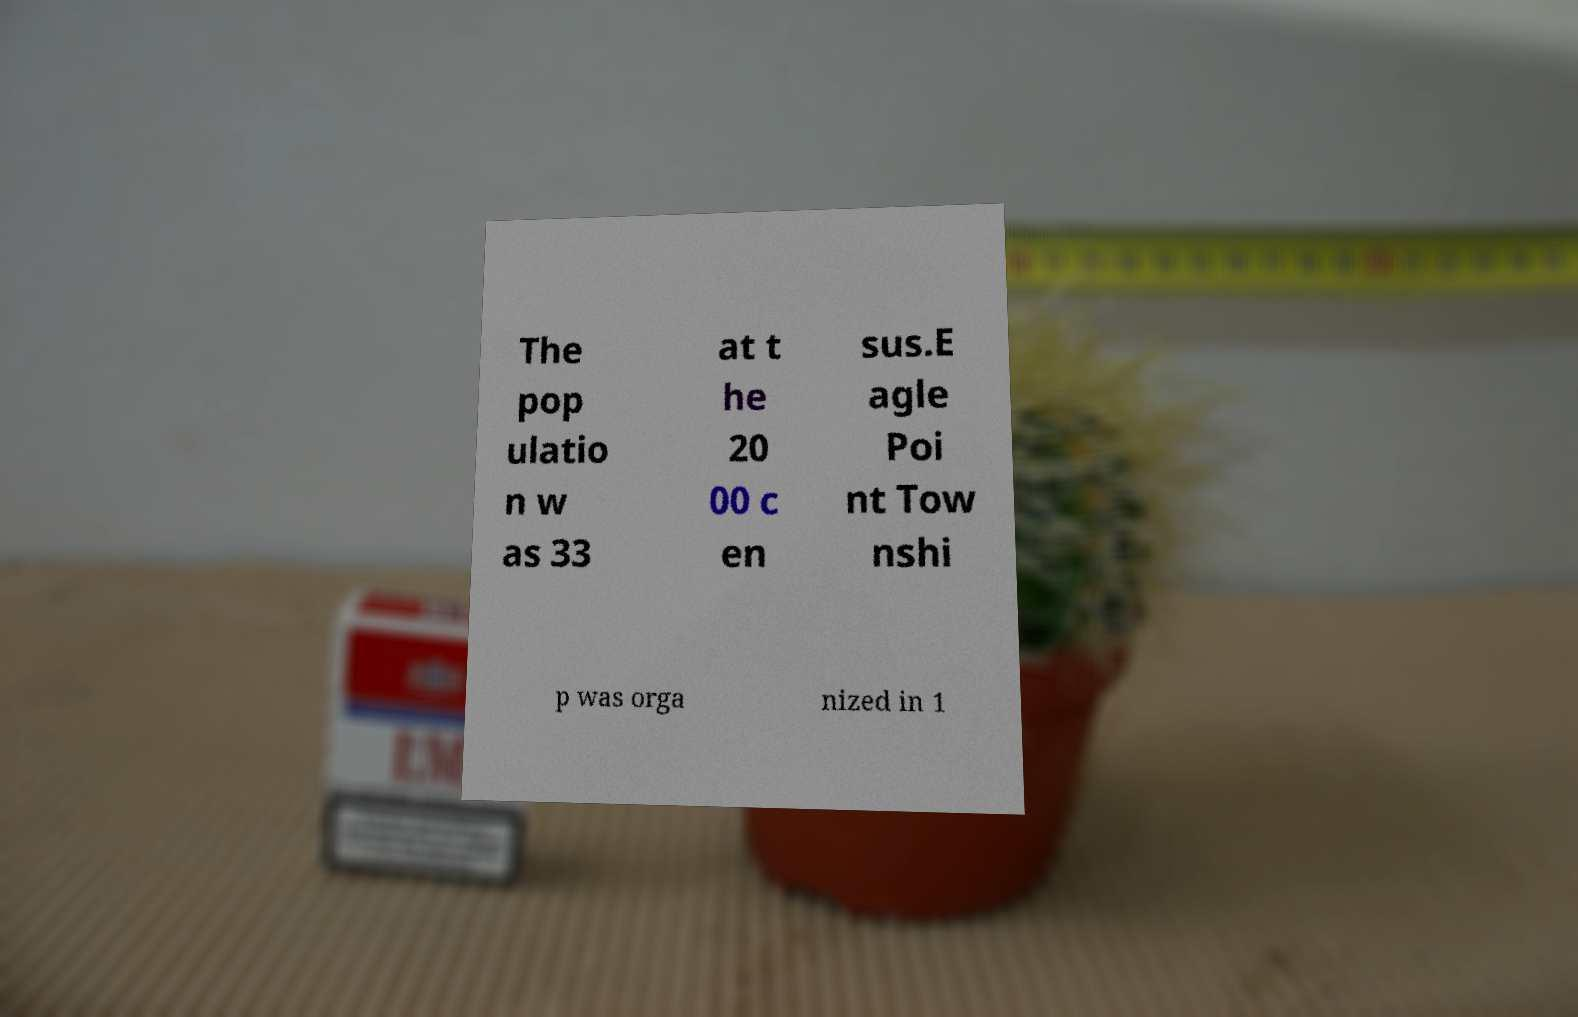Could you extract and type out the text from this image? The pop ulatio n w as 33 at t he 20 00 c en sus.E agle Poi nt Tow nshi p was orga nized in 1 